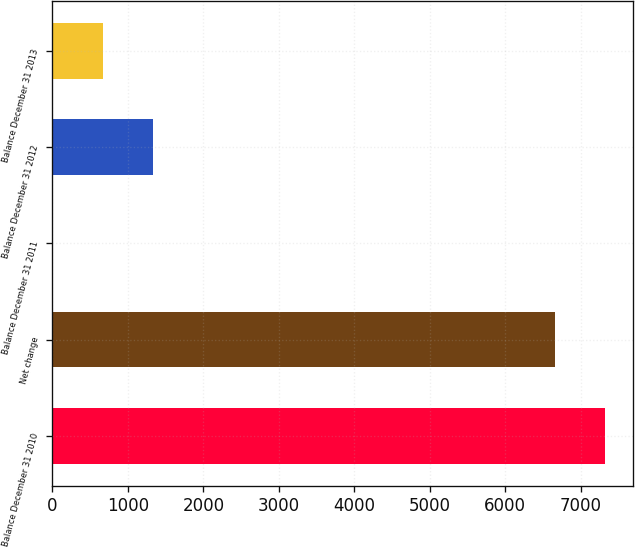Convert chart to OTSL. <chart><loc_0><loc_0><loc_500><loc_500><bar_chart><fcel>Balance December 31 2010<fcel>Net change<fcel>Balance December 31 2011<fcel>Balance December 31 2012<fcel>Balance December 31 2013<nl><fcel>7321.6<fcel>6656<fcel>3<fcel>1334.2<fcel>668.6<nl></chart> 